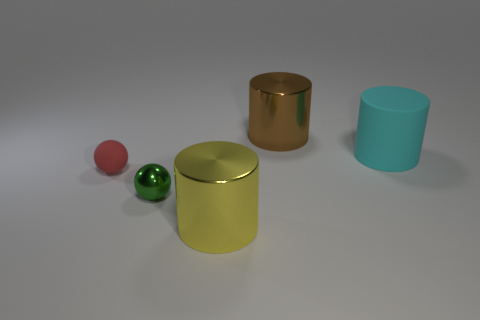What is the material of the other thing that is the same shape as the small green shiny object?
Provide a short and direct response. Rubber. How many red rubber things are the same size as the green ball?
Provide a succinct answer. 1. Does the cyan object have the same size as the metallic sphere?
Make the answer very short. No. There is a thing that is both in front of the tiny red matte object and on the left side of the yellow object; what is its size?
Provide a succinct answer. Small. Are there more red things that are in front of the small red thing than yellow shiny things left of the large cyan cylinder?
Provide a short and direct response. No. What is the color of the other large shiny object that is the same shape as the yellow shiny object?
Keep it short and to the point. Brown. Do the shiny cylinder that is to the right of the big yellow shiny cylinder and the matte cylinder have the same color?
Offer a terse response. No. How many tiny green metal blocks are there?
Ensure brevity in your answer.  0. Do the big cylinder in front of the cyan matte thing and the green sphere have the same material?
Keep it short and to the point. Yes. Is there anything else that is the same material as the large cyan object?
Your answer should be very brief. Yes. 